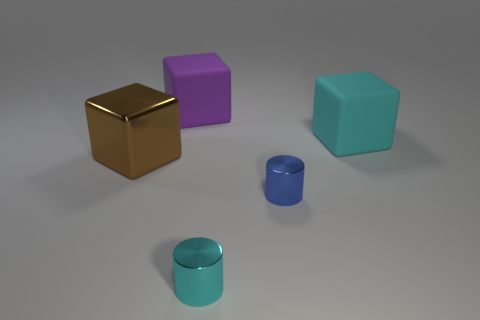There's a small object in front of the purple one; what shape is it? The small object in front of the purple one is cylindrical. It has a circular top view and a height shorter than its diameter, making it appear stout. How does the size of this cylindrical object compare to the others? This cylindrical object is the smallest among them in terms of both height and volume. The cube shapes are much larger by comparison, with the purple and cyan cubes being roughly similar in size and the gold cube appearing slightly larger. 